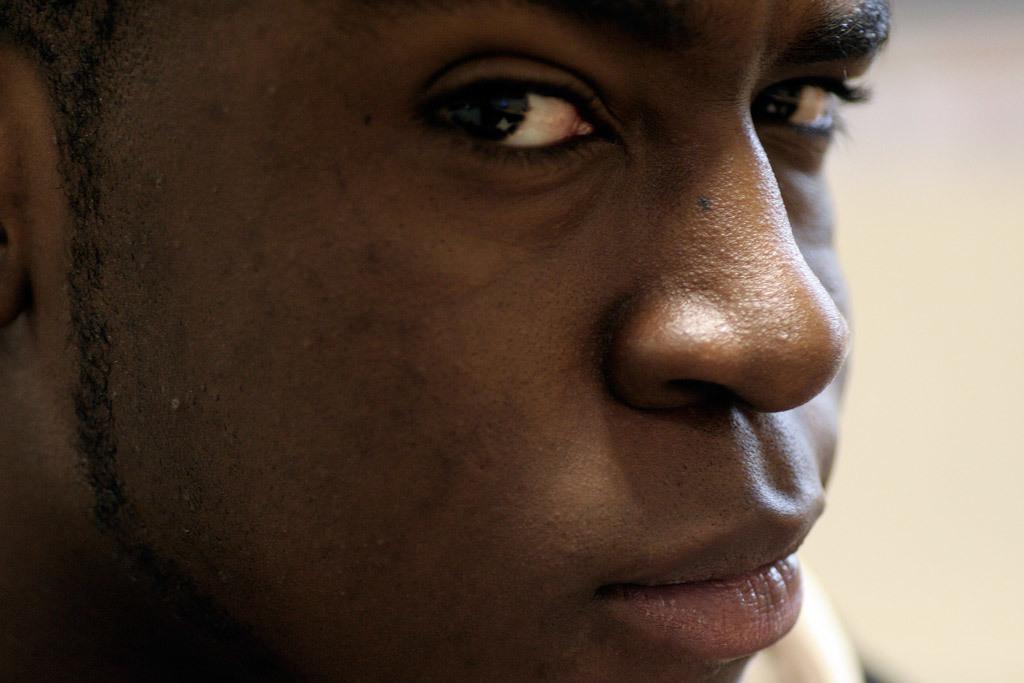Describe this image in one or two sentences. In this image I can see a person. 